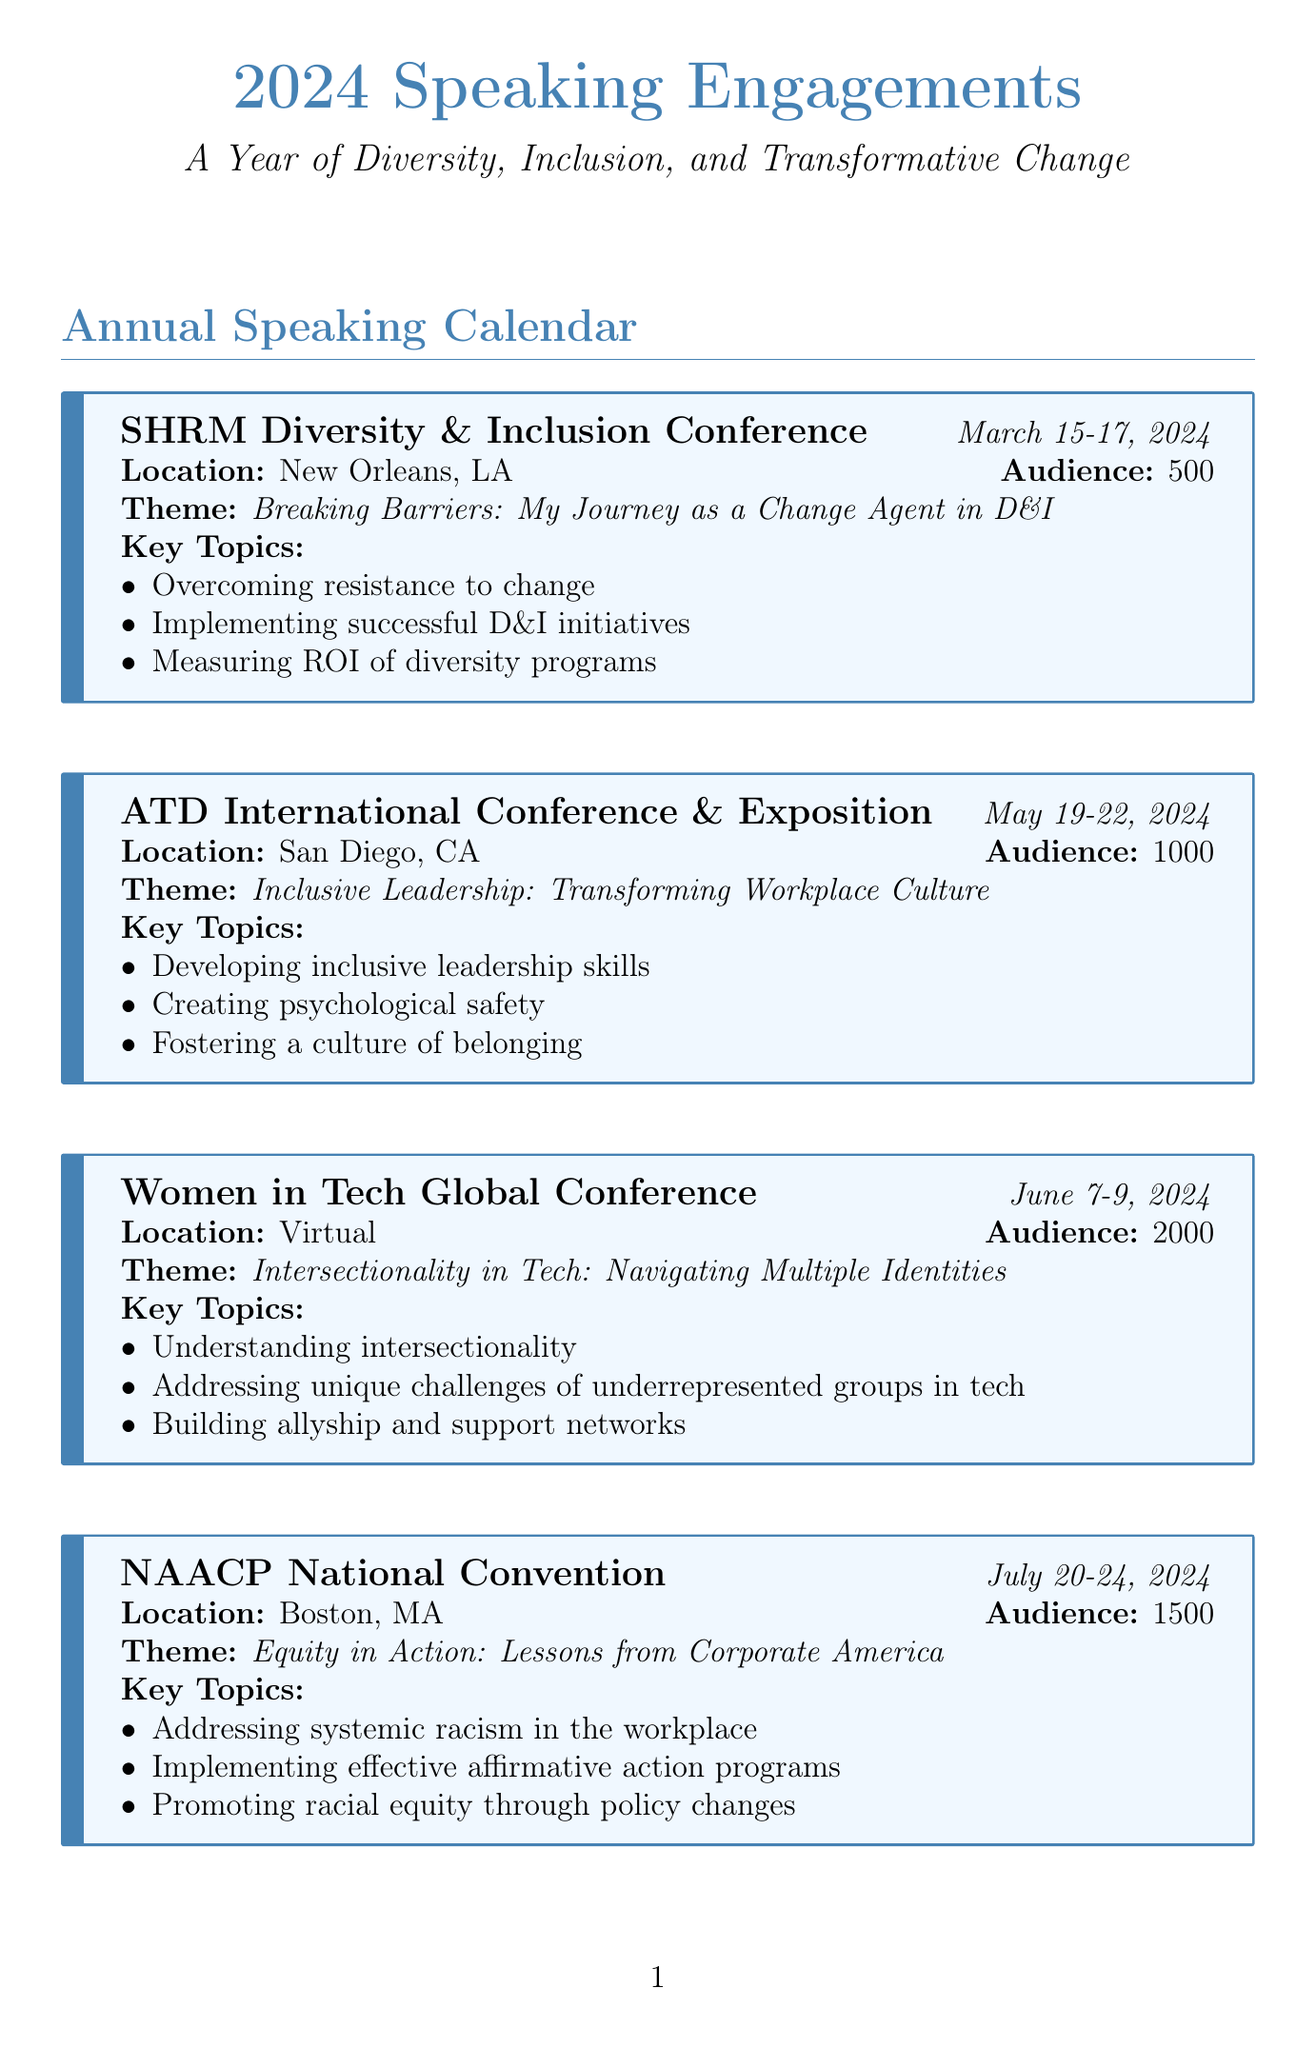What is the date of the SHRM Diversity & Inclusion Conference? The date is specified in the calendar entry for the SHRM Diversity & Inclusion Conference.
Answer: March 15-17, 2024 How many attendees are expected at the National Diversity Council Summit? The expected audience size is mentioned in the event details for the National Diversity Council Summit.
Answer: 750 What is the theme for the Women in Tech Global Conference? The theme is outlined in the corresponding event entry for the Women in Tech Global Conference.
Answer: Intersectionality in Tech: Navigating Multiple Identities Where will the ATD International Conference & Exposition take place? The location is specified in the event details for the ATD International Conference & Exposition.
Answer: San Diego, CA What key topic is included in the presentation for the Out & Equal Workplace Summit? Key topics are listed in the event details for the Out & Equal Workplace Summit.
Answer: Creating truly inclusive policies for LGBTQ+ employees Which event focuses on equity in the corporate world? The event name focusing on equity is provided in the document.
Answer: NAACP National Convention What is the audience size for the Women in Tech Global Conference? The audience size is given in the details of the Women in Tech Global Conference entry.
Answer: 2000 Which event covers the theme of promoting racial equity? The event related to promoting racial equity is detailed in the entry.
Answer: NAACP National Convention 